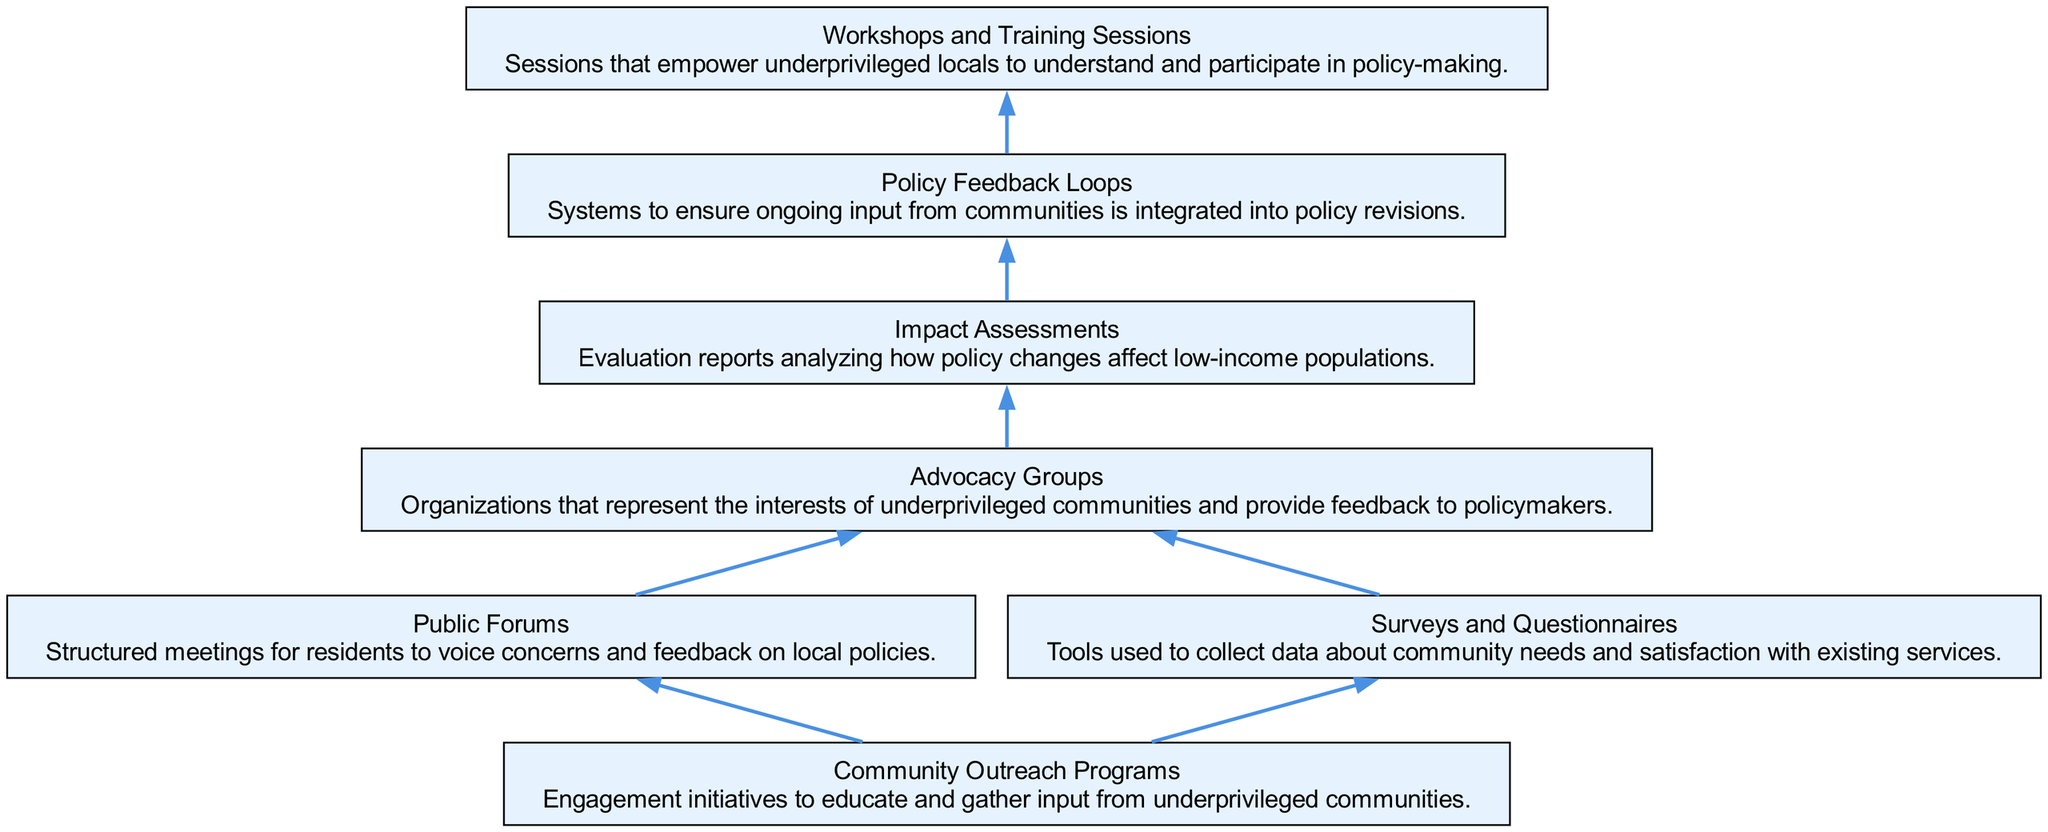What is the first node in the diagram? The first node visually appears at the bottom of the diagram, which is "Community Outreach Programs." This node serves as the starting point of the flow, leading to the subsequent connections.
Answer: Community Outreach Programs How many nodes are present in the diagram? By counting the distinct elements represented as nodes, there are a total of seven nodes in the diagram: Community Outreach Programs, Public Forums, Surveys and Questionnaires, Advocacy Groups, Impact Assessments, Policy Feedback Loops, and Workshops and Training Sessions.
Answer: 7 Which nodes are directly connected to Public Forums? From the diagram's structure, Public Forums is directly connected to one node: Advocacy Groups. This relationship indicates feedback flow from forums to the advocacy groups representing community interests.
Answer: Advocacy Groups What follows after Impact Assessments in the flow of the diagram? Following Impact Assessments, the next node is Policy Feedback Loops. This indicates that the assessments inform the feedback mechanisms for future policy iterations.
Answer: Policy Feedback Loops What is the purpose of Workshops and Training Sessions in the diagram? Workshops and Training Sessions serve to empower underprivileged locals by providing them with the knowledge and skills necessary to engage in the policy-making process. This end node indicates the culmination of the feedback integration process.
Answer: Empowerment Which two nodes lead into Advocacy Groups? Both Public Forums and Surveys and Questionnaires provide input to the Advocacy Groups, reflecting how community feedback is channeled through structured interactions and surveys to advocate for policy changes.
Answer: Public Forums, Surveys and Questionnaires How does the diagram illustrate the feedback loop concept? The diagram includes a Policy Feedback Loops node, which emerges after Impact Assessments, showing that community feedback is continually integrated into policy revisions. This reflects the iterative nature of policy-making and responsiveness to community input.
Answer: Policy Feedback Loops What kind of programs initiate engagement with underprivileged communities? The initiating programs for community engagement as shown in the diagram are labeled "Community Outreach Programs," which are designed to educate and gather feedback. This is vital for understanding community needs.
Answer: Community Outreach Programs 